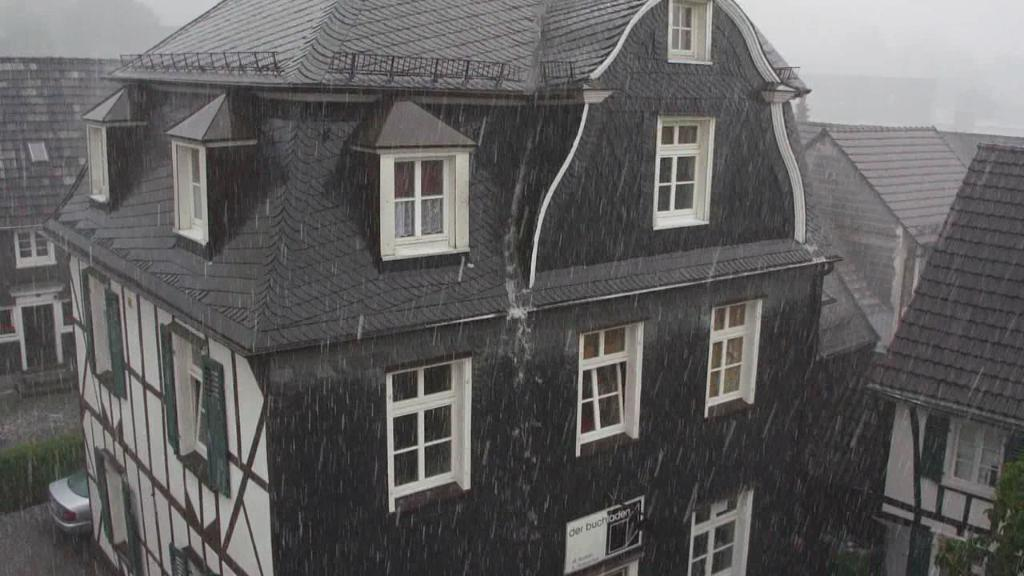What type of structures can be seen in the image? There are buildings in the image. What mode of transportation is visible on the road? There is a car on the road in the image. Can you tell me how many maids are standing next to the car in the image? There are no maids present in the image; it only features buildings and a car on the road. What type of pleasure can be seen being derived from the car in the image? There is no indication of pleasure being derived from the car in the image; it is simply a parked car on the road. 